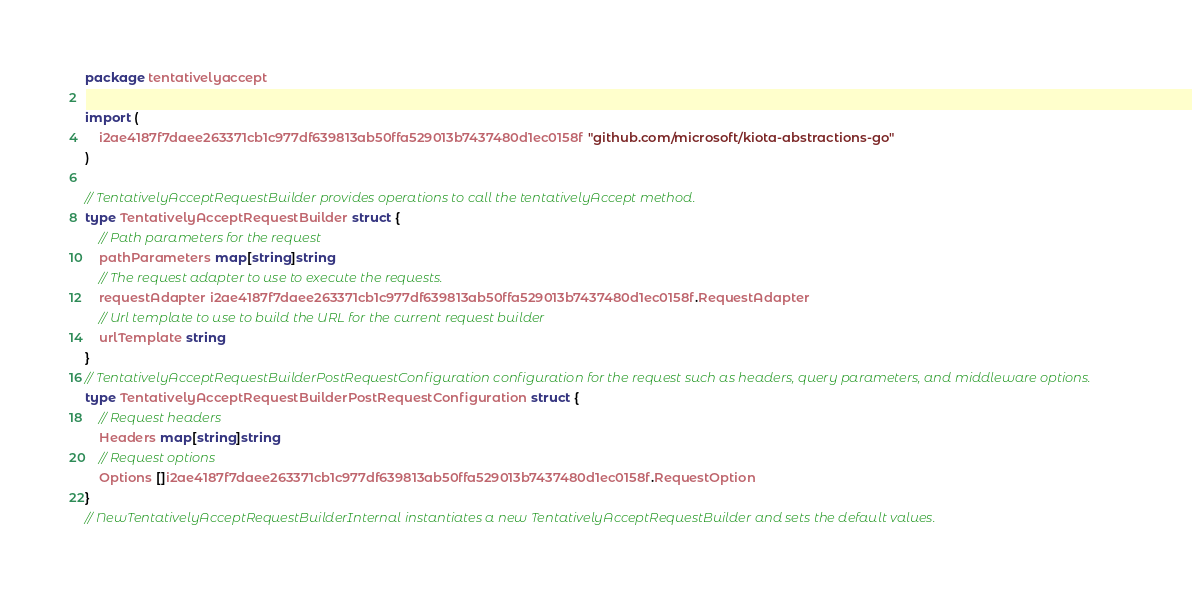<code> <loc_0><loc_0><loc_500><loc_500><_Go_>package tentativelyaccept

import (
    i2ae4187f7daee263371cb1c977df639813ab50ffa529013b7437480d1ec0158f "github.com/microsoft/kiota-abstractions-go"
)

// TentativelyAcceptRequestBuilder provides operations to call the tentativelyAccept method.
type TentativelyAcceptRequestBuilder struct {
    // Path parameters for the request
    pathParameters map[string]string
    // The request adapter to use to execute the requests.
    requestAdapter i2ae4187f7daee263371cb1c977df639813ab50ffa529013b7437480d1ec0158f.RequestAdapter
    // Url template to use to build the URL for the current request builder
    urlTemplate string
}
// TentativelyAcceptRequestBuilderPostRequestConfiguration configuration for the request such as headers, query parameters, and middleware options.
type TentativelyAcceptRequestBuilderPostRequestConfiguration struct {
    // Request headers
    Headers map[string]string
    // Request options
    Options []i2ae4187f7daee263371cb1c977df639813ab50ffa529013b7437480d1ec0158f.RequestOption
}
// NewTentativelyAcceptRequestBuilderInternal instantiates a new TentativelyAcceptRequestBuilder and sets the default values.</code> 